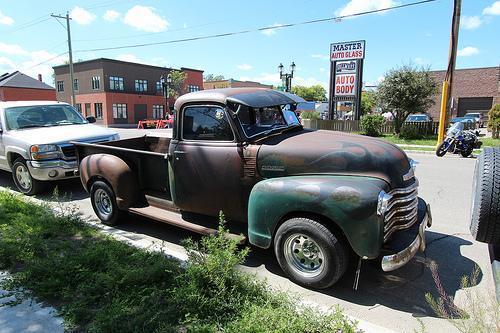How many antique vehicles are shown?
Give a very brief answer. 1. 